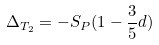<formula> <loc_0><loc_0><loc_500><loc_500>\Delta _ { T _ { 2 } } = - S _ { P } ( 1 - \frac { 3 } { 5 } d )</formula> 